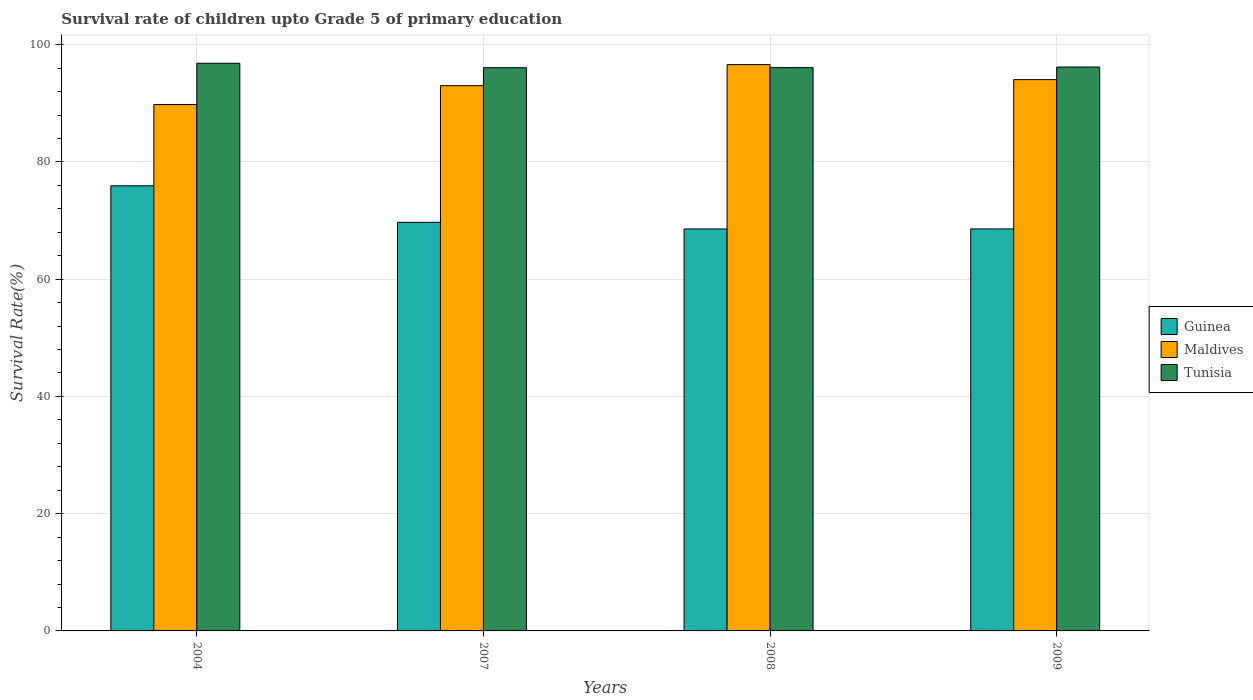How many groups of bars are there?
Your answer should be compact. 4. Are the number of bars on each tick of the X-axis equal?
Your response must be concise. Yes. How many bars are there on the 2nd tick from the right?
Give a very brief answer. 3. What is the label of the 1st group of bars from the left?
Provide a succinct answer. 2004. What is the survival rate of children in Guinea in 2009?
Make the answer very short. 68.58. Across all years, what is the maximum survival rate of children in Tunisia?
Provide a succinct answer. 96.84. Across all years, what is the minimum survival rate of children in Tunisia?
Offer a very short reply. 96.08. In which year was the survival rate of children in Tunisia maximum?
Ensure brevity in your answer.  2004. What is the total survival rate of children in Maldives in the graph?
Offer a very short reply. 373.46. What is the difference between the survival rate of children in Guinea in 2004 and that in 2009?
Your answer should be very brief. 7.36. What is the difference between the survival rate of children in Guinea in 2008 and the survival rate of children in Tunisia in 2007?
Your answer should be compact. -27.5. What is the average survival rate of children in Guinea per year?
Offer a very short reply. 70.7. In the year 2007, what is the difference between the survival rate of children in Maldives and survival rate of children in Tunisia?
Your response must be concise. -3.06. In how many years, is the survival rate of children in Maldives greater than 88 %?
Provide a short and direct response. 4. What is the ratio of the survival rate of children in Tunisia in 2004 to that in 2007?
Ensure brevity in your answer.  1.01. Is the survival rate of children in Tunisia in 2004 less than that in 2009?
Provide a short and direct response. No. Is the difference between the survival rate of children in Maldives in 2008 and 2009 greater than the difference between the survival rate of children in Tunisia in 2008 and 2009?
Your answer should be compact. Yes. What is the difference between the highest and the second highest survival rate of children in Tunisia?
Offer a very short reply. 0.64. What is the difference between the highest and the lowest survival rate of children in Guinea?
Give a very brief answer. 7.36. Is the sum of the survival rate of children in Maldives in 2004 and 2008 greater than the maximum survival rate of children in Tunisia across all years?
Your answer should be very brief. Yes. What does the 2nd bar from the left in 2007 represents?
Your answer should be compact. Maldives. What does the 2nd bar from the right in 2008 represents?
Provide a succinct answer. Maldives. Are all the bars in the graph horizontal?
Offer a terse response. No. How many years are there in the graph?
Your response must be concise. 4. What is the difference between two consecutive major ticks on the Y-axis?
Your answer should be compact. 20. Are the values on the major ticks of Y-axis written in scientific E-notation?
Ensure brevity in your answer.  No. Does the graph contain any zero values?
Your answer should be compact. No. Where does the legend appear in the graph?
Provide a succinct answer. Center right. How are the legend labels stacked?
Your answer should be compact. Vertical. What is the title of the graph?
Keep it short and to the point. Survival rate of children upto Grade 5 of primary education. Does "South Sudan" appear as one of the legend labels in the graph?
Offer a terse response. No. What is the label or title of the Y-axis?
Make the answer very short. Survival Rate(%). What is the Survival Rate(%) of Guinea in 2004?
Provide a short and direct response. 75.93. What is the Survival Rate(%) of Maldives in 2004?
Your response must be concise. 89.79. What is the Survival Rate(%) in Tunisia in 2004?
Ensure brevity in your answer.  96.84. What is the Survival Rate(%) of Guinea in 2007?
Provide a succinct answer. 69.7. What is the Survival Rate(%) of Maldives in 2007?
Ensure brevity in your answer.  93.01. What is the Survival Rate(%) of Tunisia in 2007?
Provide a succinct answer. 96.08. What is the Survival Rate(%) in Guinea in 2008?
Keep it short and to the point. 68.57. What is the Survival Rate(%) in Maldives in 2008?
Provide a succinct answer. 96.61. What is the Survival Rate(%) in Tunisia in 2008?
Give a very brief answer. 96.09. What is the Survival Rate(%) of Guinea in 2009?
Ensure brevity in your answer.  68.58. What is the Survival Rate(%) of Maldives in 2009?
Your response must be concise. 94.04. What is the Survival Rate(%) of Tunisia in 2009?
Ensure brevity in your answer.  96.19. Across all years, what is the maximum Survival Rate(%) in Guinea?
Your answer should be very brief. 75.93. Across all years, what is the maximum Survival Rate(%) in Maldives?
Keep it short and to the point. 96.61. Across all years, what is the maximum Survival Rate(%) of Tunisia?
Ensure brevity in your answer.  96.84. Across all years, what is the minimum Survival Rate(%) of Guinea?
Keep it short and to the point. 68.57. Across all years, what is the minimum Survival Rate(%) of Maldives?
Offer a terse response. 89.79. Across all years, what is the minimum Survival Rate(%) in Tunisia?
Provide a succinct answer. 96.08. What is the total Survival Rate(%) of Guinea in the graph?
Make the answer very short. 282.79. What is the total Survival Rate(%) in Maldives in the graph?
Offer a very short reply. 373.46. What is the total Survival Rate(%) of Tunisia in the graph?
Your answer should be very brief. 385.19. What is the difference between the Survival Rate(%) of Guinea in 2004 and that in 2007?
Your response must be concise. 6.23. What is the difference between the Survival Rate(%) of Maldives in 2004 and that in 2007?
Your answer should be compact. -3.22. What is the difference between the Survival Rate(%) in Tunisia in 2004 and that in 2007?
Your answer should be very brief. 0.76. What is the difference between the Survival Rate(%) of Guinea in 2004 and that in 2008?
Provide a short and direct response. 7.36. What is the difference between the Survival Rate(%) of Maldives in 2004 and that in 2008?
Give a very brief answer. -6.82. What is the difference between the Survival Rate(%) of Tunisia in 2004 and that in 2008?
Provide a short and direct response. 0.75. What is the difference between the Survival Rate(%) in Guinea in 2004 and that in 2009?
Provide a succinct answer. 7.36. What is the difference between the Survival Rate(%) of Maldives in 2004 and that in 2009?
Offer a very short reply. -4.25. What is the difference between the Survival Rate(%) in Tunisia in 2004 and that in 2009?
Offer a terse response. 0.64. What is the difference between the Survival Rate(%) in Guinea in 2007 and that in 2008?
Provide a succinct answer. 1.13. What is the difference between the Survival Rate(%) in Maldives in 2007 and that in 2008?
Ensure brevity in your answer.  -3.59. What is the difference between the Survival Rate(%) of Tunisia in 2007 and that in 2008?
Keep it short and to the point. -0.01. What is the difference between the Survival Rate(%) of Guinea in 2007 and that in 2009?
Keep it short and to the point. 1.12. What is the difference between the Survival Rate(%) of Maldives in 2007 and that in 2009?
Keep it short and to the point. -1.03. What is the difference between the Survival Rate(%) in Tunisia in 2007 and that in 2009?
Make the answer very short. -0.12. What is the difference between the Survival Rate(%) of Guinea in 2008 and that in 2009?
Provide a succinct answer. -0.01. What is the difference between the Survival Rate(%) in Maldives in 2008 and that in 2009?
Your answer should be compact. 2.56. What is the difference between the Survival Rate(%) in Tunisia in 2008 and that in 2009?
Your answer should be compact. -0.1. What is the difference between the Survival Rate(%) of Guinea in 2004 and the Survival Rate(%) of Maldives in 2007?
Provide a short and direct response. -17.08. What is the difference between the Survival Rate(%) in Guinea in 2004 and the Survival Rate(%) in Tunisia in 2007?
Your answer should be compact. -20.14. What is the difference between the Survival Rate(%) in Maldives in 2004 and the Survival Rate(%) in Tunisia in 2007?
Make the answer very short. -6.28. What is the difference between the Survival Rate(%) in Guinea in 2004 and the Survival Rate(%) in Maldives in 2008?
Keep it short and to the point. -20.67. What is the difference between the Survival Rate(%) of Guinea in 2004 and the Survival Rate(%) of Tunisia in 2008?
Your answer should be compact. -20.15. What is the difference between the Survival Rate(%) of Maldives in 2004 and the Survival Rate(%) of Tunisia in 2008?
Provide a succinct answer. -6.3. What is the difference between the Survival Rate(%) in Guinea in 2004 and the Survival Rate(%) in Maldives in 2009?
Offer a terse response. -18.11. What is the difference between the Survival Rate(%) in Guinea in 2004 and the Survival Rate(%) in Tunisia in 2009?
Give a very brief answer. -20.26. What is the difference between the Survival Rate(%) of Maldives in 2004 and the Survival Rate(%) of Tunisia in 2009?
Keep it short and to the point. -6.4. What is the difference between the Survival Rate(%) in Guinea in 2007 and the Survival Rate(%) in Maldives in 2008?
Provide a succinct answer. -26.91. What is the difference between the Survival Rate(%) in Guinea in 2007 and the Survival Rate(%) in Tunisia in 2008?
Your answer should be very brief. -26.39. What is the difference between the Survival Rate(%) of Maldives in 2007 and the Survival Rate(%) of Tunisia in 2008?
Make the answer very short. -3.08. What is the difference between the Survival Rate(%) in Guinea in 2007 and the Survival Rate(%) in Maldives in 2009?
Ensure brevity in your answer.  -24.34. What is the difference between the Survival Rate(%) of Guinea in 2007 and the Survival Rate(%) of Tunisia in 2009?
Your answer should be very brief. -26.49. What is the difference between the Survival Rate(%) of Maldives in 2007 and the Survival Rate(%) of Tunisia in 2009?
Provide a short and direct response. -3.18. What is the difference between the Survival Rate(%) of Guinea in 2008 and the Survival Rate(%) of Maldives in 2009?
Offer a very short reply. -25.47. What is the difference between the Survival Rate(%) of Guinea in 2008 and the Survival Rate(%) of Tunisia in 2009?
Your answer should be compact. -27.62. What is the difference between the Survival Rate(%) in Maldives in 2008 and the Survival Rate(%) in Tunisia in 2009?
Make the answer very short. 0.42. What is the average Survival Rate(%) of Guinea per year?
Provide a succinct answer. 70.7. What is the average Survival Rate(%) in Maldives per year?
Your response must be concise. 93.36. What is the average Survival Rate(%) of Tunisia per year?
Offer a very short reply. 96.3. In the year 2004, what is the difference between the Survival Rate(%) of Guinea and Survival Rate(%) of Maldives?
Offer a terse response. -13.86. In the year 2004, what is the difference between the Survival Rate(%) of Guinea and Survival Rate(%) of Tunisia?
Give a very brief answer. -20.9. In the year 2004, what is the difference between the Survival Rate(%) in Maldives and Survival Rate(%) in Tunisia?
Your answer should be very brief. -7.04. In the year 2007, what is the difference between the Survival Rate(%) of Guinea and Survival Rate(%) of Maldives?
Give a very brief answer. -23.31. In the year 2007, what is the difference between the Survival Rate(%) in Guinea and Survival Rate(%) in Tunisia?
Offer a terse response. -26.37. In the year 2007, what is the difference between the Survival Rate(%) in Maldives and Survival Rate(%) in Tunisia?
Ensure brevity in your answer.  -3.06. In the year 2008, what is the difference between the Survival Rate(%) in Guinea and Survival Rate(%) in Maldives?
Ensure brevity in your answer.  -28.04. In the year 2008, what is the difference between the Survival Rate(%) of Guinea and Survival Rate(%) of Tunisia?
Give a very brief answer. -27.52. In the year 2008, what is the difference between the Survival Rate(%) in Maldives and Survival Rate(%) in Tunisia?
Offer a terse response. 0.52. In the year 2009, what is the difference between the Survival Rate(%) in Guinea and Survival Rate(%) in Maldives?
Offer a very short reply. -25.47. In the year 2009, what is the difference between the Survival Rate(%) of Guinea and Survival Rate(%) of Tunisia?
Ensure brevity in your answer.  -27.61. In the year 2009, what is the difference between the Survival Rate(%) in Maldives and Survival Rate(%) in Tunisia?
Offer a terse response. -2.15. What is the ratio of the Survival Rate(%) of Guinea in 2004 to that in 2007?
Make the answer very short. 1.09. What is the ratio of the Survival Rate(%) in Maldives in 2004 to that in 2007?
Your response must be concise. 0.97. What is the ratio of the Survival Rate(%) in Tunisia in 2004 to that in 2007?
Your answer should be compact. 1.01. What is the ratio of the Survival Rate(%) in Guinea in 2004 to that in 2008?
Keep it short and to the point. 1.11. What is the ratio of the Survival Rate(%) in Maldives in 2004 to that in 2008?
Offer a terse response. 0.93. What is the ratio of the Survival Rate(%) of Guinea in 2004 to that in 2009?
Provide a short and direct response. 1.11. What is the ratio of the Survival Rate(%) of Maldives in 2004 to that in 2009?
Your answer should be compact. 0.95. What is the ratio of the Survival Rate(%) of Guinea in 2007 to that in 2008?
Your response must be concise. 1.02. What is the ratio of the Survival Rate(%) in Maldives in 2007 to that in 2008?
Provide a short and direct response. 0.96. What is the ratio of the Survival Rate(%) in Tunisia in 2007 to that in 2008?
Ensure brevity in your answer.  1. What is the ratio of the Survival Rate(%) in Guinea in 2007 to that in 2009?
Your answer should be very brief. 1.02. What is the ratio of the Survival Rate(%) of Maldives in 2007 to that in 2009?
Your response must be concise. 0.99. What is the ratio of the Survival Rate(%) of Guinea in 2008 to that in 2009?
Make the answer very short. 1. What is the ratio of the Survival Rate(%) in Maldives in 2008 to that in 2009?
Your answer should be very brief. 1.03. What is the difference between the highest and the second highest Survival Rate(%) of Guinea?
Give a very brief answer. 6.23. What is the difference between the highest and the second highest Survival Rate(%) of Maldives?
Give a very brief answer. 2.56. What is the difference between the highest and the second highest Survival Rate(%) of Tunisia?
Provide a succinct answer. 0.64. What is the difference between the highest and the lowest Survival Rate(%) of Guinea?
Keep it short and to the point. 7.36. What is the difference between the highest and the lowest Survival Rate(%) in Maldives?
Provide a short and direct response. 6.82. What is the difference between the highest and the lowest Survival Rate(%) of Tunisia?
Offer a terse response. 0.76. 